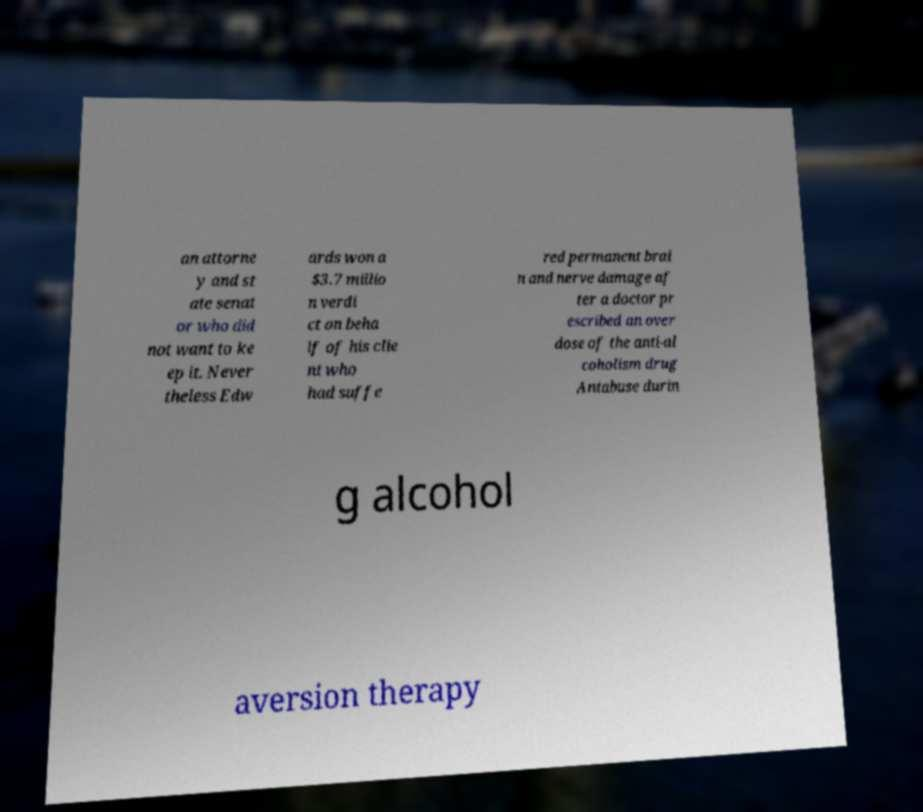Please identify and transcribe the text found in this image. an attorne y and st ate senat or who did not want to ke ep it. Never theless Edw ards won a $3.7 millio n verdi ct on beha lf of his clie nt who had suffe red permanent brai n and nerve damage af ter a doctor pr escribed an over dose of the anti-al coholism drug Antabuse durin g alcohol aversion therapy 